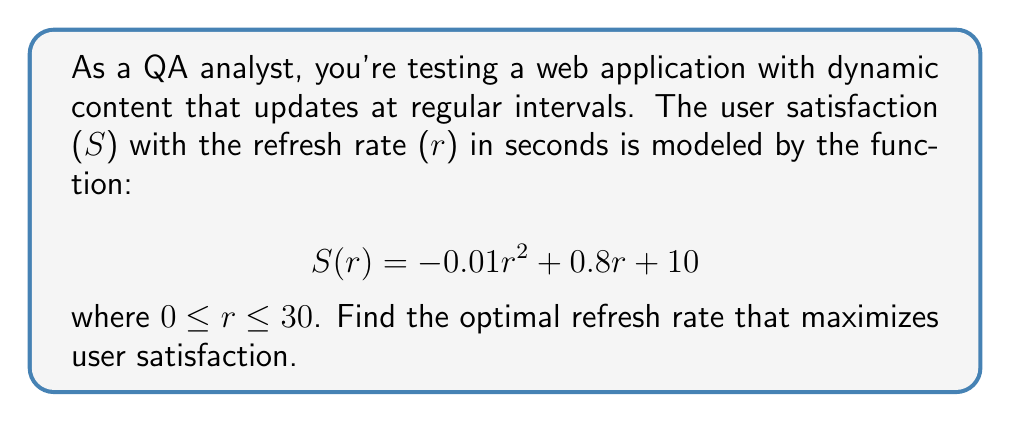Solve this math problem. To find the optimal refresh rate that maximizes user satisfaction, we need to find the maximum of the function $S(r)$. This can be done by finding where the derivative of $S(r)$ equals zero.

1. First, let's find the derivative of $S(r)$:
   $$S'(r) = -0.02r + 0.8$$

2. Now, set $S'(r) = 0$ and solve for $r$:
   $$-0.02r + 0.8 = 0$$
   $$-0.02r = -0.8$$
   $$r = 40$$

3. To confirm this is a maximum (not a minimum), we can check the second derivative:
   $$S''(r) = -0.02$$
   Since $S''(r)$ is negative, this confirms we have found a maximum.

4. However, we need to check if this value is within our domain of $0 \leq r \leq 30$. Since 40 is outside this range, we need to check the endpoints of our domain.

5. Evaluate $S(r)$ at $r = 0$ and $r = 30$:
   $$S(0) = 10$$
   $$S(30) = -0.01(30)^2 + 0.8(30) + 10 = 19$$

6. The maximum value within our domain occurs at $r = 30$ seconds.

Therefore, the optimal refresh rate that maximizes user satisfaction is 30 seconds.
Answer: The optimal refresh rate is 30 seconds. 